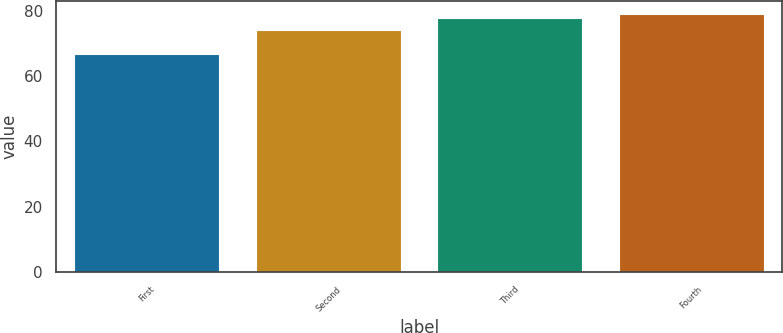Convert chart to OTSL. <chart><loc_0><loc_0><loc_500><loc_500><bar_chart><fcel>First<fcel>Second<fcel>Third<fcel>Fourth<nl><fcel>66.93<fcel>74.19<fcel>77.93<fcel>79.07<nl></chart> 